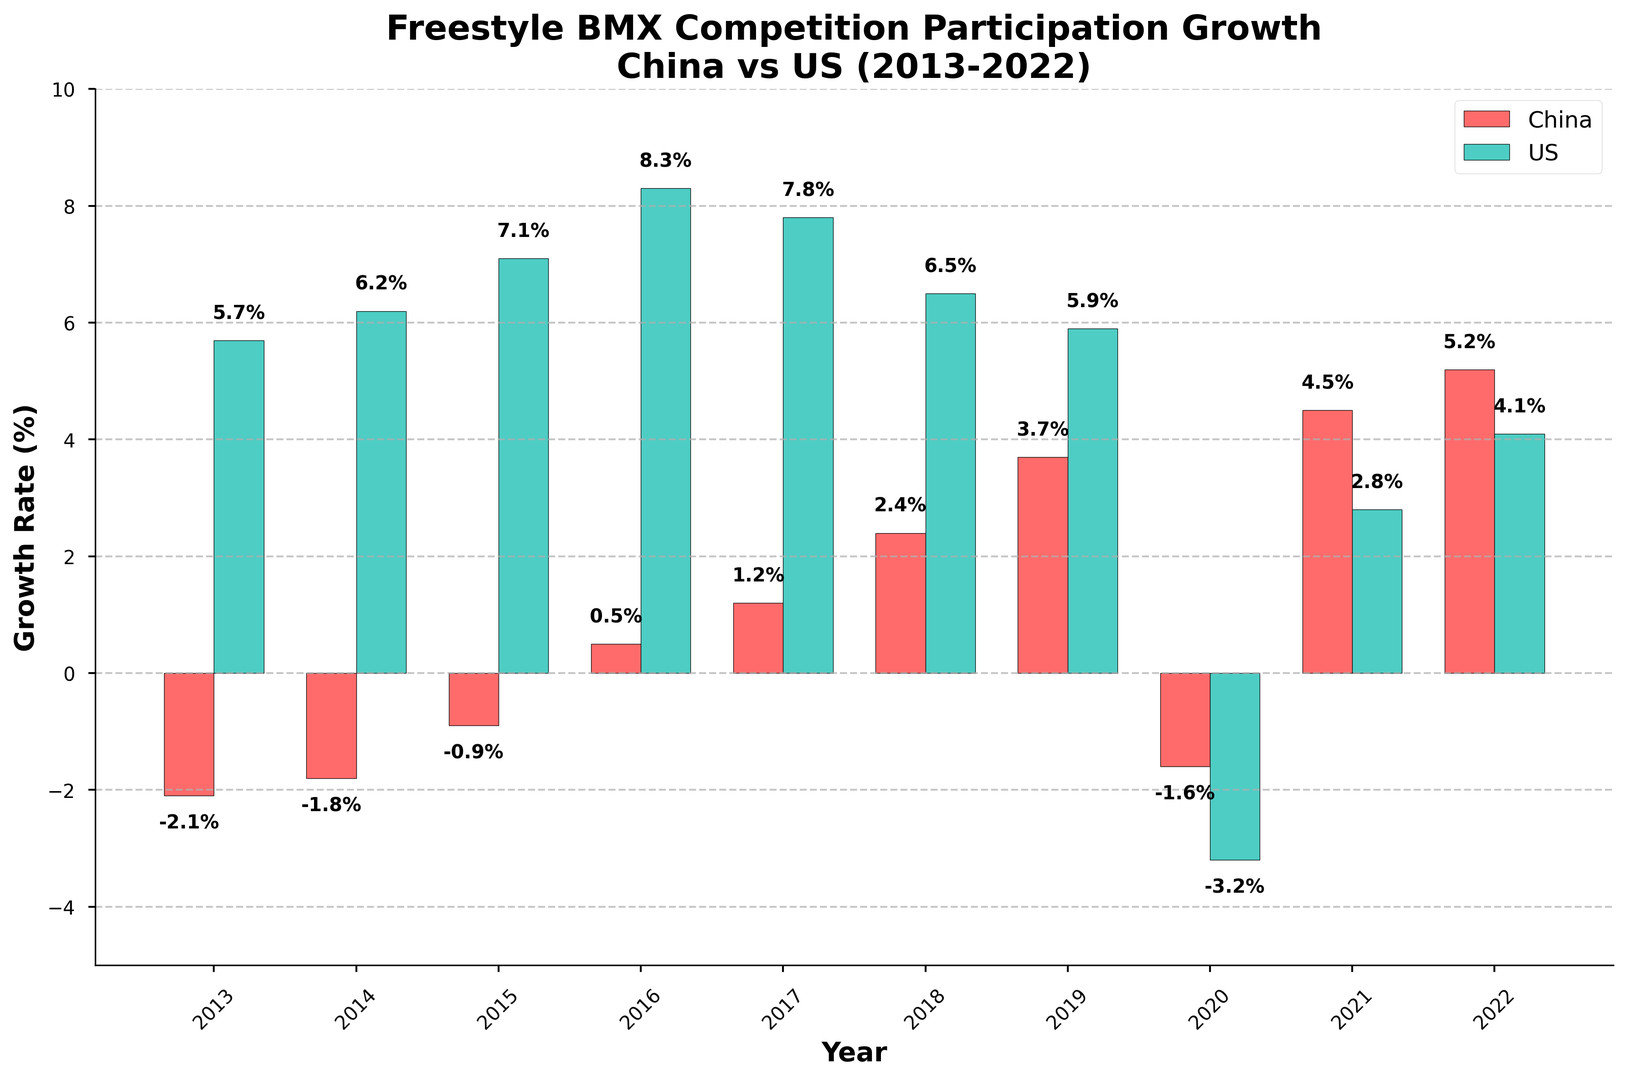What is the growth rate for freestyle BMX competition participation in China in 2016? The 2016 bar for China is labeled with the growth rate value. This value is represented in a red bar on the chart.
Answer: 0.5% Which year shows a decline in participation for both China and the US? Look for the bars that are both below zero. They represent years with negative growth rates for both countries.
Answer: 2020 In which year did the US have the highest growth rate? The height of the US bars (green) varies, with the tallest bar indicating the year with the highest growth rate.
Answer: 2016 What's the average growth rate for China between 2019 and 2022? Sum the growth rates for China from 2019 to 2022 and divide by the number of years: (3.7 + 4.5 + 5.2) / 3
Answer: 4.47% How does the US growth rate in 2014 compare to that in 2021? Compare the heights of the US bar for 2014 and 2021, represented by green bars.
Answer: 2014 is higher Which year showed the most significant positive growth difference between China and the US? Look for the largest positive difference between the heights of the China bar (red) and US bar (green) for each year.
Answer: 2021 What is the difference in growth rates between China and the US for 2020? Subtract the growth rate for the US in 2020 (-3.2%) from the growth rate for China in 2020 (-1.6%): -1.6% - (-3.2%) = 1.6%
Answer: 1.6% In which years did China's participation growth turn from negative to positive and continue to increase? Identify years where the China bar (red) goes from below zero to above zero and continues to grow.
Answer: 2015, 2016, 2017 How many years did the US experience a growth rate above 6%? Count the number of green bars that have heights above the 6% mark.
Answer: 5 Which country had a more stable growth rate progression from 2013 to 2022? Visually analyze the consistency of the bar heights for each country across the years.
Answer: China 